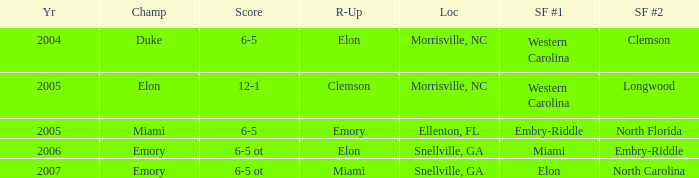Which team was the second semi finalist in 2007? North Carolina. 